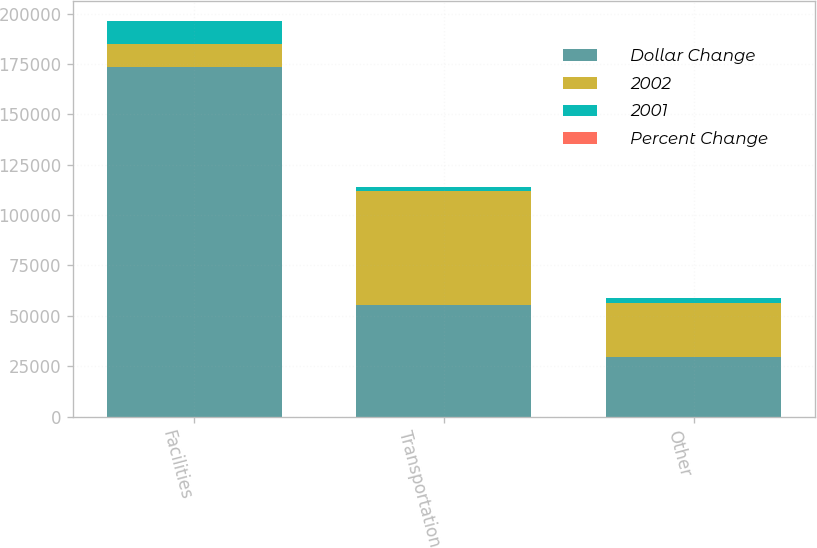Convert chart. <chart><loc_0><loc_0><loc_500><loc_500><stacked_bar_chart><ecel><fcel>Facilities<fcel>Transportation<fcel>Other<nl><fcel>Dollar Change<fcel>173610<fcel>55167<fcel>29447<nl><fcel>2002<fcel>11378<fcel>56972<fcel>27080<nl><fcel>2001<fcel>11378<fcel>1805<fcel>2367<nl><fcel>Percent Change<fcel>6.6<fcel>3.3<fcel>8<nl></chart> 